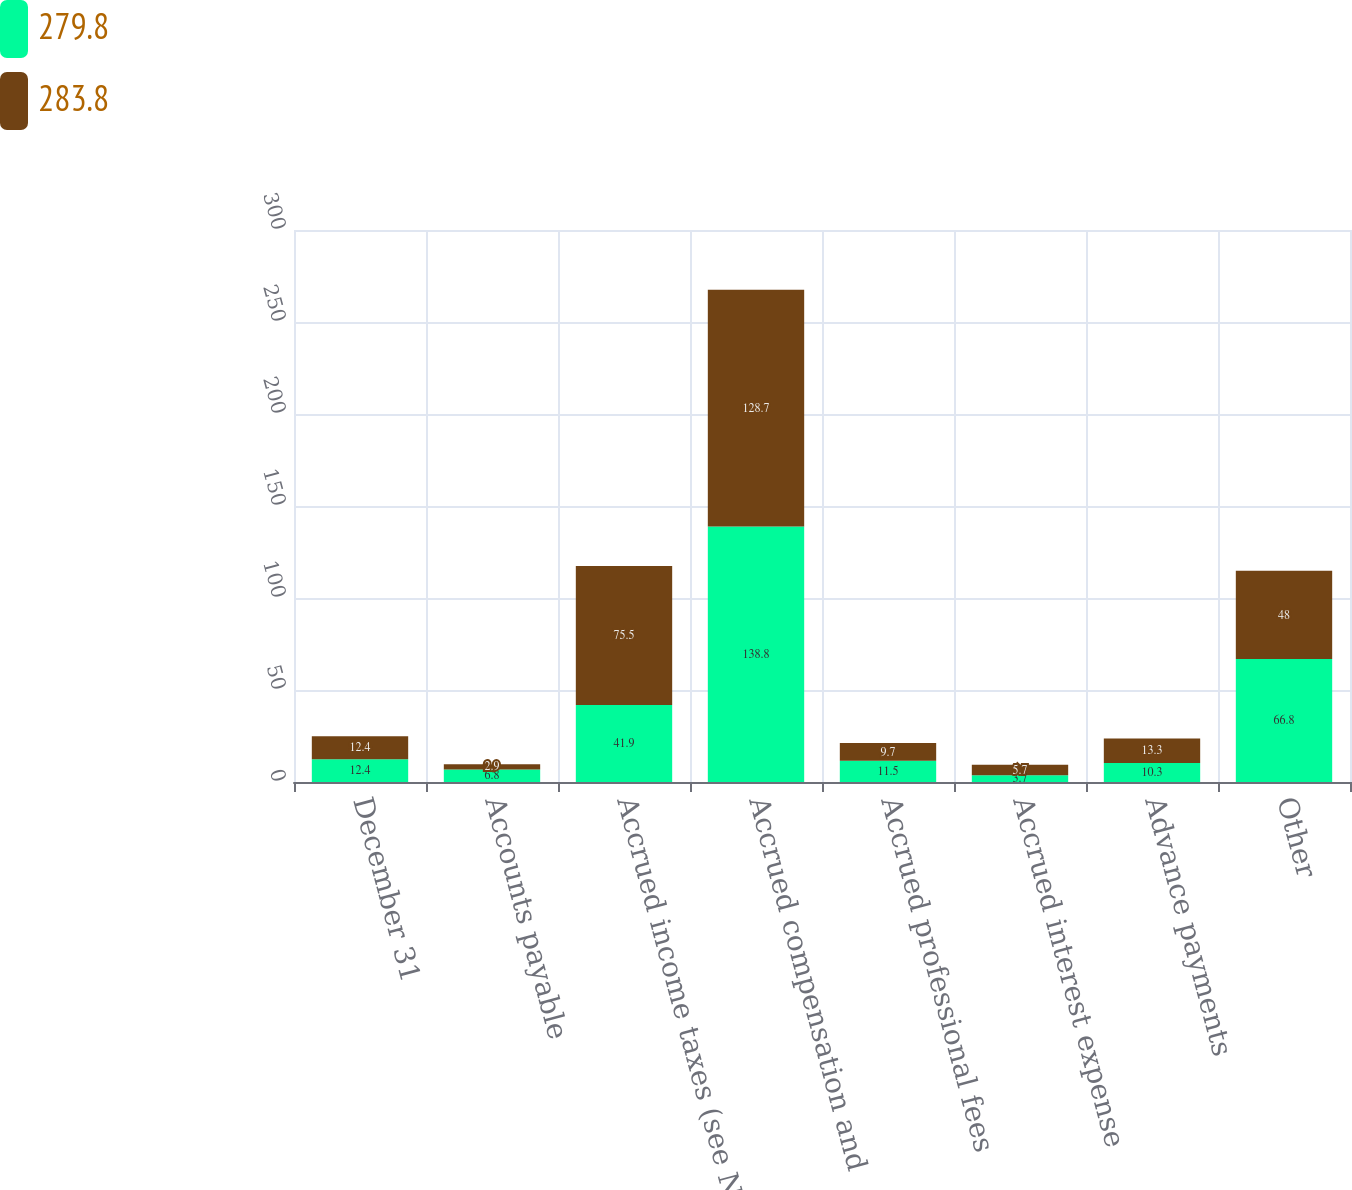<chart> <loc_0><loc_0><loc_500><loc_500><stacked_bar_chart><ecel><fcel>December 31<fcel>Accounts payable<fcel>Accrued income taxes (see Note<fcel>Accrued compensation and<fcel>Accrued professional fees<fcel>Accrued interest expense<fcel>Advance payments<fcel>Other<nl><fcel>279.8<fcel>12.4<fcel>6.8<fcel>41.9<fcel>138.8<fcel>11.5<fcel>3.7<fcel>10.3<fcel>66.8<nl><fcel>283.8<fcel>12.4<fcel>2.9<fcel>75.5<fcel>128.7<fcel>9.7<fcel>5.7<fcel>13.3<fcel>48<nl></chart> 